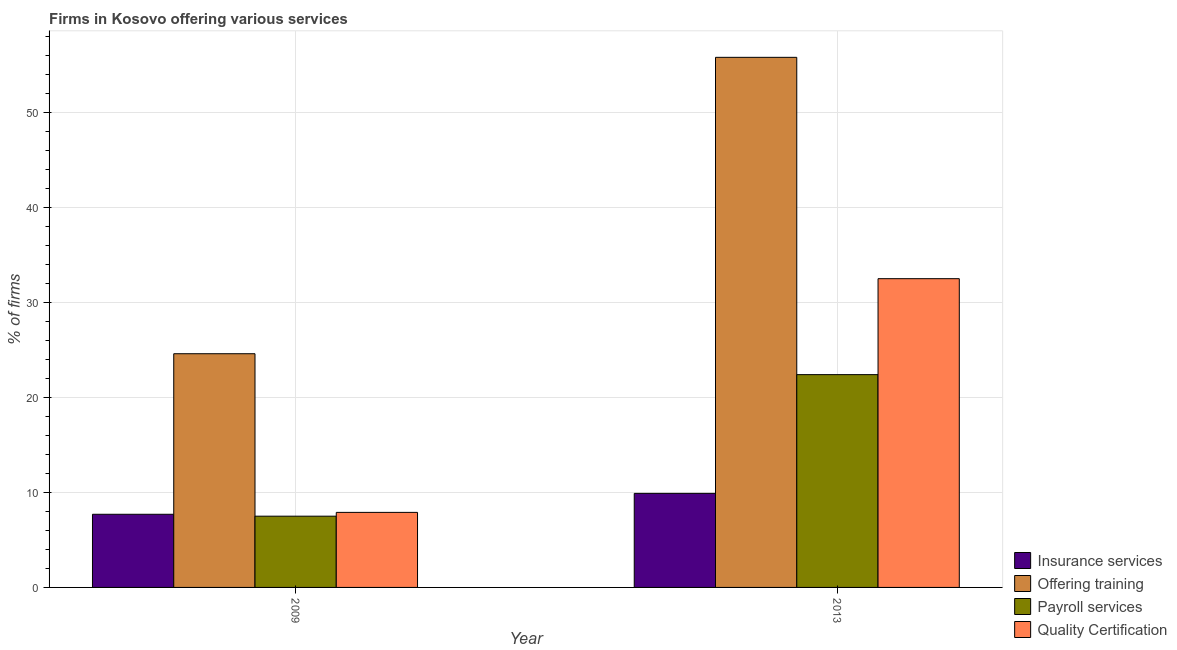How many groups of bars are there?
Your response must be concise. 2. Are the number of bars per tick equal to the number of legend labels?
Offer a terse response. Yes. Are the number of bars on each tick of the X-axis equal?
Your answer should be very brief. Yes. What is the label of the 1st group of bars from the left?
Your response must be concise. 2009. What is the percentage of firms offering training in 2009?
Your response must be concise. 24.6. Across all years, what is the maximum percentage of firms offering training?
Your answer should be very brief. 55.8. In which year was the percentage of firms offering insurance services maximum?
Make the answer very short. 2013. What is the difference between the percentage of firms offering training in 2009 and that in 2013?
Make the answer very short. -31.2. What is the difference between the percentage of firms offering payroll services in 2009 and the percentage of firms offering training in 2013?
Give a very brief answer. -14.9. What is the average percentage of firms offering quality certification per year?
Offer a very short reply. 20.2. In the year 2009, what is the difference between the percentage of firms offering insurance services and percentage of firms offering quality certification?
Give a very brief answer. 0. What is the ratio of the percentage of firms offering payroll services in 2009 to that in 2013?
Make the answer very short. 0.33. Is the percentage of firms offering quality certification in 2009 less than that in 2013?
Provide a succinct answer. Yes. Is it the case that in every year, the sum of the percentage of firms offering payroll services and percentage of firms offering quality certification is greater than the sum of percentage of firms offering training and percentage of firms offering insurance services?
Keep it short and to the point. No. What does the 3rd bar from the left in 2013 represents?
Ensure brevity in your answer.  Payroll services. What does the 2nd bar from the right in 2009 represents?
Your answer should be compact. Payroll services. Is it the case that in every year, the sum of the percentage of firms offering insurance services and percentage of firms offering training is greater than the percentage of firms offering payroll services?
Offer a terse response. Yes. Are all the bars in the graph horizontal?
Provide a succinct answer. No. How many years are there in the graph?
Give a very brief answer. 2. What is the difference between two consecutive major ticks on the Y-axis?
Your response must be concise. 10. Are the values on the major ticks of Y-axis written in scientific E-notation?
Make the answer very short. No. Does the graph contain any zero values?
Make the answer very short. No. How are the legend labels stacked?
Provide a succinct answer. Vertical. What is the title of the graph?
Provide a succinct answer. Firms in Kosovo offering various services . Does "Greece" appear as one of the legend labels in the graph?
Offer a very short reply. No. What is the label or title of the X-axis?
Provide a succinct answer. Year. What is the label or title of the Y-axis?
Ensure brevity in your answer.  % of firms. What is the % of firms of Offering training in 2009?
Provide a succinct answer. 24.6. What is the % of firms of Quality Certification in 2009?
Keep it short and to the point. 7.9. What is the % of firms of Insurance services in 2013?
Keep it short and to the point. 9.9. What is the % of firms in Offering training in 2013?
Provide a succinct answer. 55.8. What is the % of firms in Payroll services in 2013?
Ensure brevity in your answer.  22.4. What is the % of firms in Quality Certification in 2013?
Offer a terse response. 32.5. Across all years, what is the maximum % of firms of Insurance services?
Make the answer very short. 9.9. Across all years, what is the maximum % of firms of Offering training?
Provide a short and direct response. 55.8. Across all years, what is the maximum % of firms in Payroll services?
Keep it short and to the point. 22.4. Across all years, what is the maximum % of firms in Quality Certification?
Keep it short and to the point. 32.5. Across all years, what is the minimum % of firms in Offering training?
Make the answer very short. 24.6. What is the total % of firms in Offering training in the graph?
Provide a succinct answer. 80.4. What is the total % of firms of Payroll services in the graph?
Provide a succinct answer. 29.9. What is the total % of firms of Quality Certification in the graph?
Offer a terse response. 40.4. What is the difference between the % of firms in Offering training in 2009 and that in 2013?
Offer a terse response. -31.2. What is the difference between the % of firms in Payroll services in 2009 and that in 2013?
Your answer should be very brief. -14.9. What is the difference between the % of firms of Quality Certification in 2009 and that in 2013?
Keep it short and to the point. -24.6. What is the difference between the % of firms in Insurance services in 2009 and the % of firms in Offering training in 2013?
Offer a very short reply. -48.1. What is the difference between the % of firms in Insurance services in 2009 and the % of firms in Payroll services in 2013?
Make the answer very short. -14.7. What is the difference between the % of firms in Insurance services in 2009 and the % of firms in Quality Certification in 2013?
Give a very brief answer. -24.8. What is the difference between the % of firms in Offering training in 2009 and the % of firms in Payroll services in 2013?
Your response must be concise. 2.2. What is the difference between the % of firms of Payroll services in 2009 and the % of firms of Quality Certification in 2013?
Provide a succinct answer. -25. What is the average % of firms of Insurance services per year?
Provide a succinct answer. 8.8. What is the average % of firms in Offering training per year?
Your answer should be very brief. 40.2. What is the average % of firms of Payroll services per year?
Your response must be concise. 14.95. What is the average % of firms in Quality Certification per year?
Ensure brevity in your answer.  20.2. In the year 2009, what is the difference between the % of firms of Insurance services and % of firms of Offering training?
Your answer should be very brief. -16.9. In the year 2009, what is the difference between the % of firms of Insurance services and % of firms of Payroll services?
Give a very brief answer. 0.2. In the year 2009, what is the difference between the % of firms in Insurance services and % of firms in Quality Certification?
Provide a succinct answer. -0.2. In the year 2009, what is the difference between the % of firms in Offering training and % of firms in Payroll services?
Give a very brief answer. 17.1. In the year 2009, what is the difference between the % of firms of Offering training and % of firms of Quality Certification?
Your answer should be compact. 16.7. In the year 2013, what is the difference between the % of firms in Insurance services and % of firms in Offering training?
Make the answer very short. -45.9. In the year 2013, what is the difference between the % of firms of Insurance services and % of firms of Payroll services?
Keep it short and to the point. -12.5. In the year 2013, what is the difference between the % of firms in Insurance services and % of firms in Quality Certification?
Your answer should be compact. -22.6. In the year 2013, what is the difference between the % of firms of Offering training and % of firms of Payroll services?
Make the answer very short. 33.4. In the year 2013, what is the difference between the % of firms of Offering training and % of firms of Quality Certification?
Offer a terse response. 23.3. What is the ratio of the % of firms of Offering training in 2009 to that in 2013?
Ensure brevity in your answer.  0.44. What is the ratio of the % of firms in Payroll services in 2009 to that in 2013?
Provide a succinct answer. 0.33. What is the ratio of the % of firms in Quality Certification in 2009 to that in 2013?
Your response must be concise. 0.24. What is the difference between the highest and the second highest % of firms of Offering training?
Offer a terse response. 31.2. What is the difference between the highest and the second highest % of firms of Quality Certification?
Offer a very short reply. 24.6. What is the difference between the highest and the lowest % of firms of Offering training?
Give a very brief answer. 31.2. What is the difference between the highest and the lowest % of firms of Quality Certification?
Your answer should be compact. 24.6. 